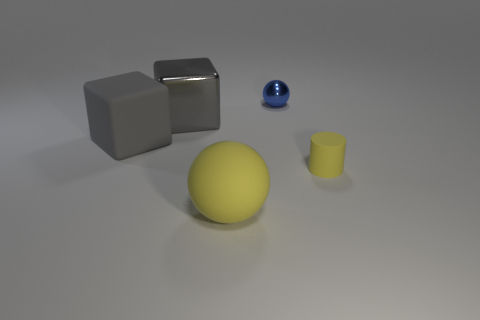Add 2 yellow spheres. How many objects exist? 7 Subtract all blocks. How many objects are left? 3 Subtract all large cubes. Subtract all big cyan metallic cubes. How many objects are left? 3 Add 4 tiny blue things. How many tiny blue things are left? 5 Add 1 tiny matte objects. How many tiny matte objects exist? 2 Subtract 0 red cylinders. How many objects are left? 5 